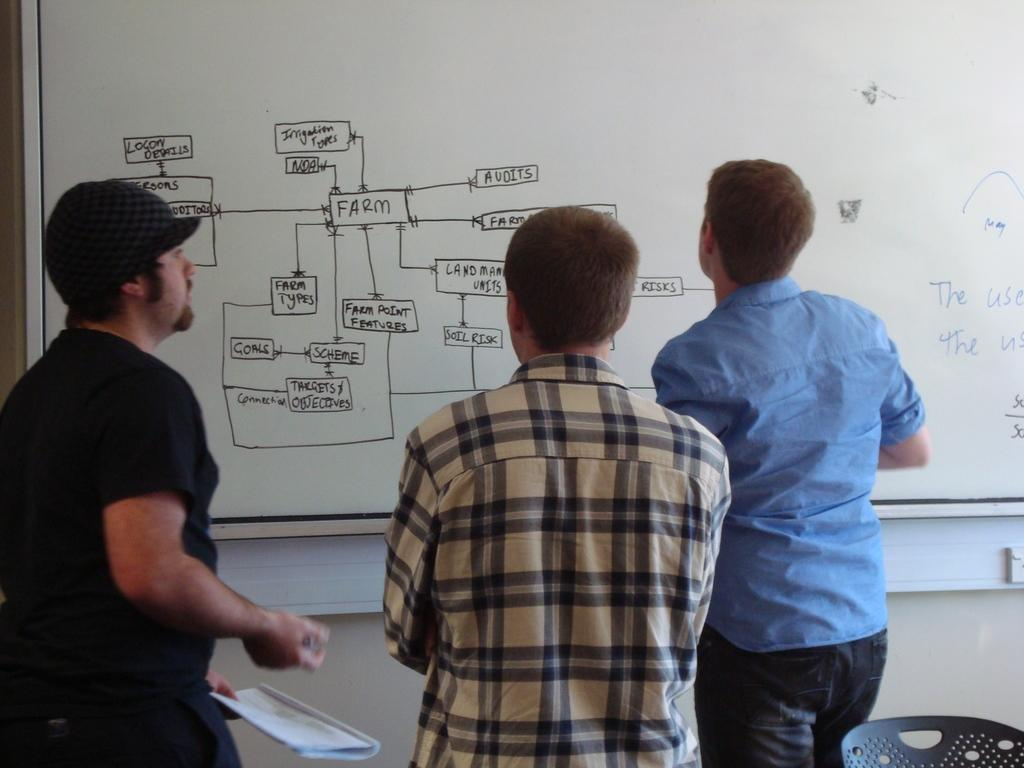<image>
Share a concise interpretation of the image provided. Some people stare at a whiteboard labeled with IRRIGATION TYPES. 